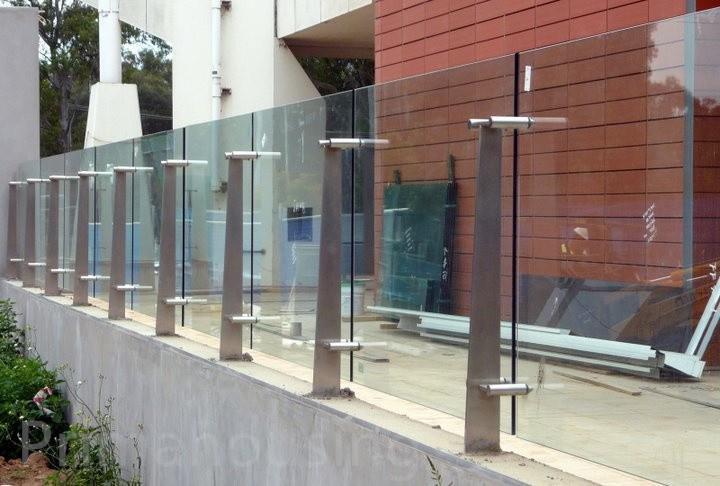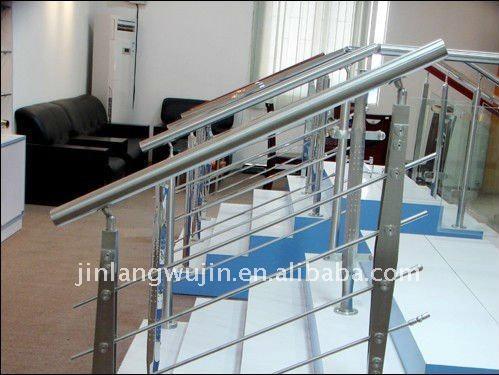The first image is the image on the left, the second image is the image on the right. For the images displayed, is the sentence "A balcony has a glass fence in one of the images." factually correct? Answer yes or no. Yes. The first image is the image on the left, the second image is the image on the right. Examine the images to the left and right. Is the description "There is a glass railing." accurate? Answer yes or no. Yes. 